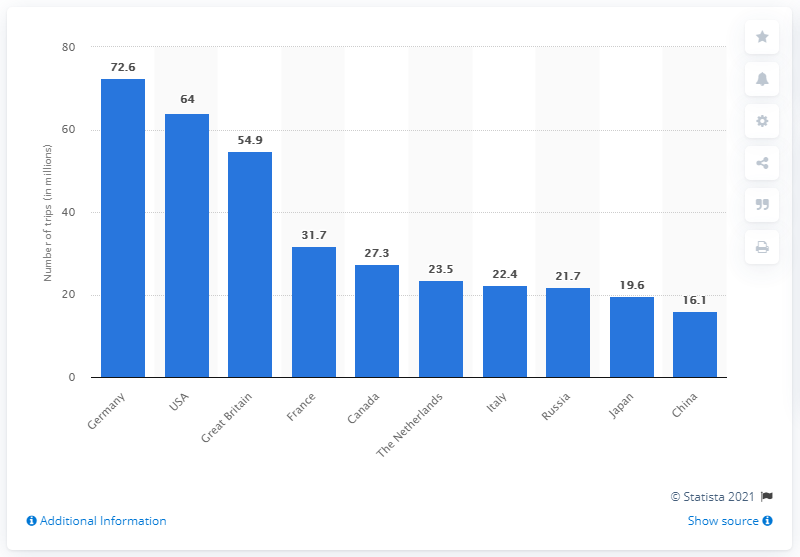Point out several critical features in this image. According to data from 2010, Germany was the country that had the most outbound travel. In 2010, Germany made 72.6 outbound trips. 